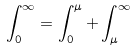Convert formula to latex. <formula><loc_0><loc_0><loc_500><loc_500>\int _ { 0 } ^ { \infty } = \int _ { 0 } ^ { \mu } + \int _ { \mu } ^ { \infty }</formula> 